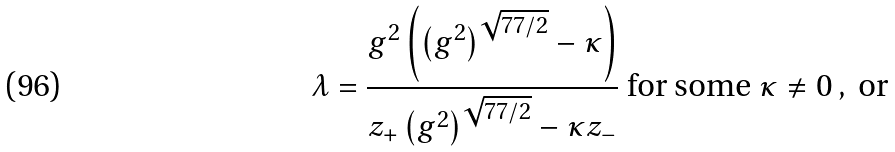Convert formula to latex. <formula><loc_0><loc_0><loc_500><loc_500>\lambda = \frac { g ^ { 2 } \left ( \left ( g ^ { 2 } \right ) ^ { \sqrt { 7 7 / 2 } } - \kappa \right ) } { z _ { + } \left ( g ^ { 2 } \right ) ^ { \sqrt { 7 7 / 2 } } - \kappa z _ { - } } \text { for some } \kappa \neq 0 \, , \text {  or}</formula> 